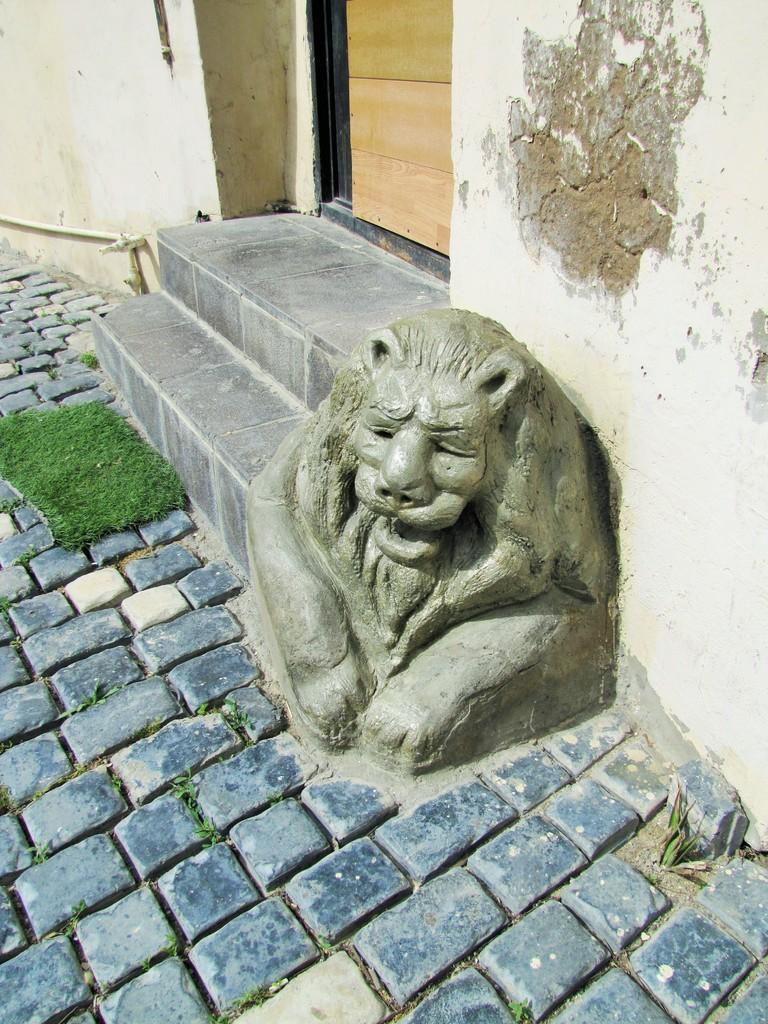Can you describe this image briefly? In this image we can see a sculpture, steps, door and wall. At the bottom of the image there is the floor. On the right side of the image there is the grass. 